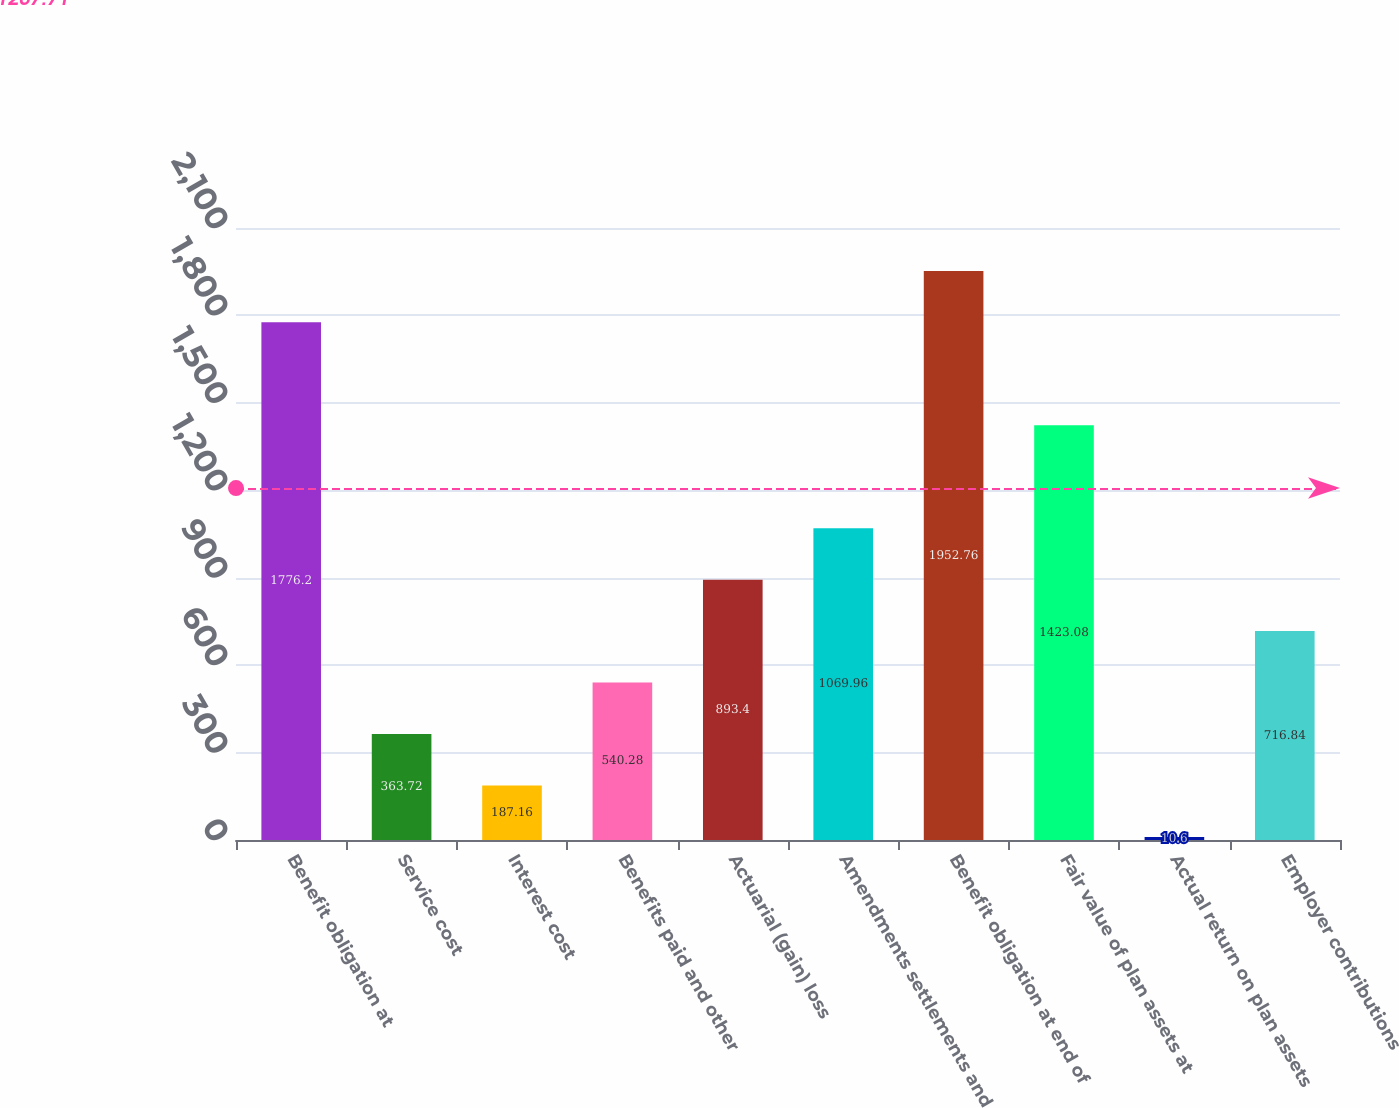<chart> <loc_0><loc_0><loc_500><loc_500><bar_chart><fcel>Benefit obligation at<fcel>Service cost<fcel>Interest cost<fcel>Benefits paid and other<fcel>Actuarial (gain) loss<fcel>Amendments settlements and<fcel>Benefit obligation at end of<fcel>Fair value of plan assets at<fcel>Actual return on plan assets<fcel>Employer contributions<nl><fcel>1776.2<fcel>363.72<fcel>187.16<fcel>540.28<fcel>893.4<fcel>1069.96<fcel>1952.76<fcel>1423.08<fcel>10.6<fcel>716.84<nl></chart> 